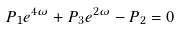Convert formula to latex. <formula><loc_0><loc_0><loc_500><loc_500>P _ { 1 } e ^ { 4 \omega } + P _ { 3 } e ^ { 2 \omega } - P _ { 2 } = 0</formula> 